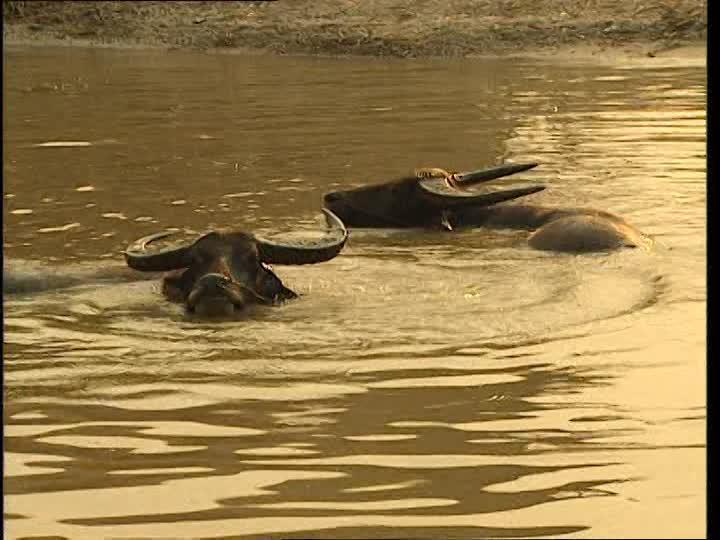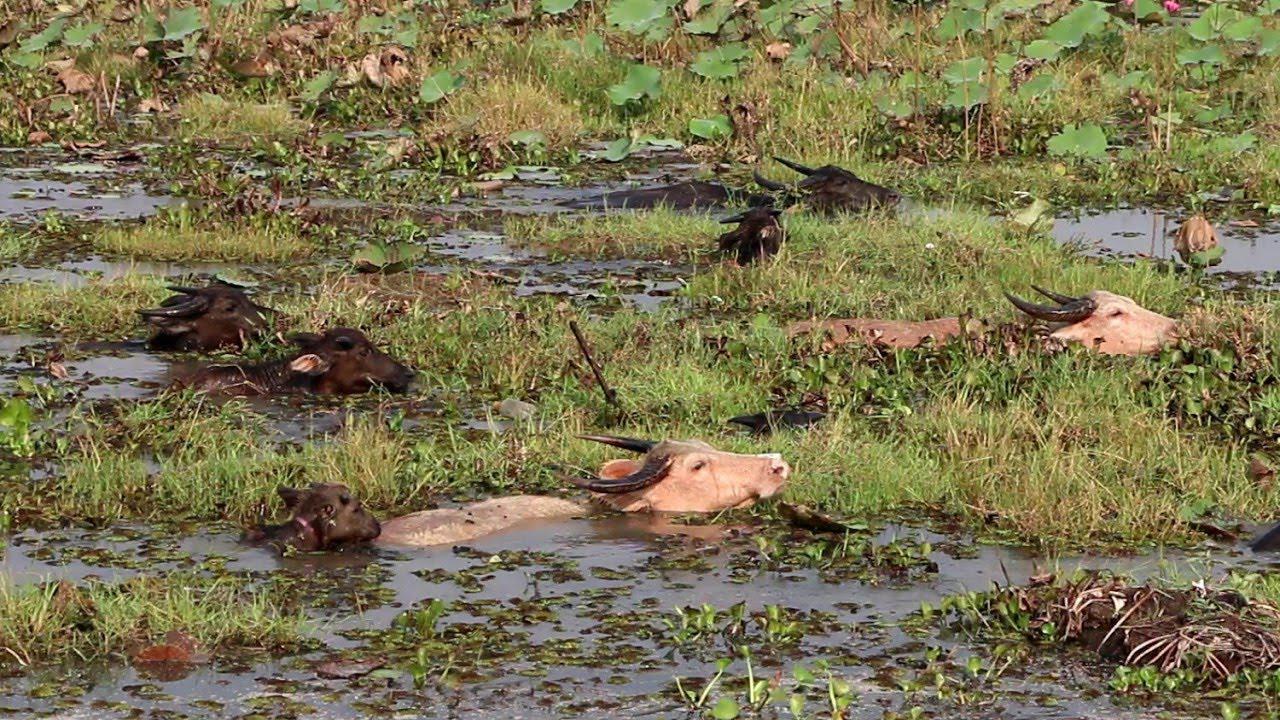The first image is the image on the left, the second image is the image on the right. Analyze the images presented: Is the assertion "The left image contains no more than one water buffalo swimming in water." valid? Answer yes or no. No. The first image is the image on the left, the second image is the image on the right. Given the left and right images, does the statement "The combined images contain no more than three water buffalo, all of them in water to their chins." hold true? Answer yes or no. No. 